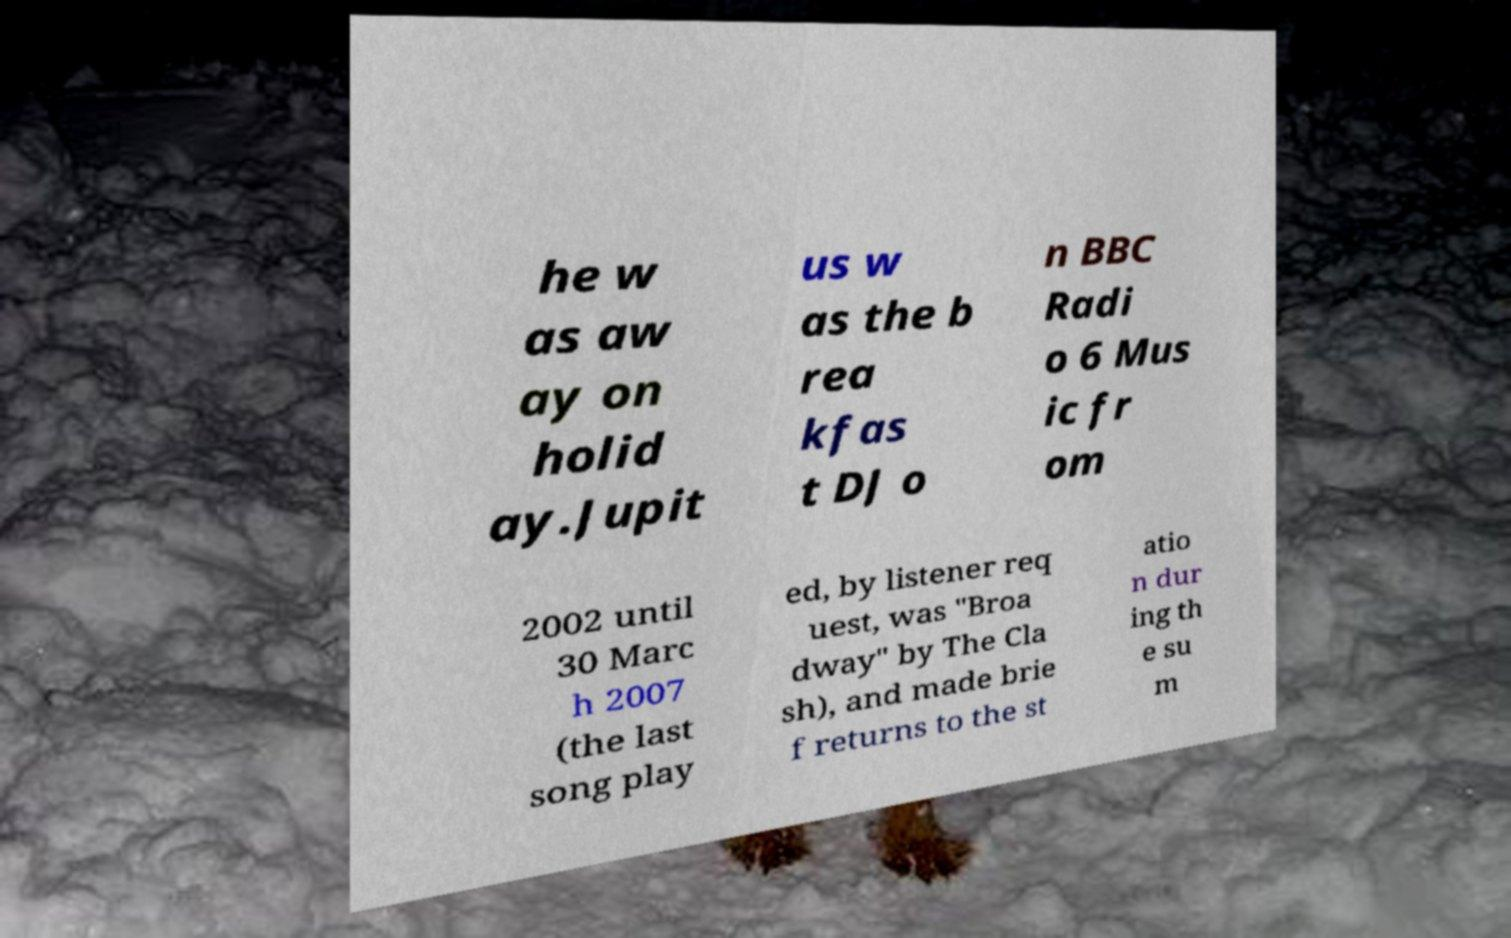Could you assist in decoding the text presented in this image and type it out clearly? he w as aw ay on holid ay.Jupit us w as the b rea kfas t DJ o n BBC Radi o 6 Mus ic fr om 2002 until 30 Marc h 2007 (the last song play ed, by listener req uest, was "Broa dway" by The Cla sh), and made brie f returns to the st atio n dur ing th e su m 